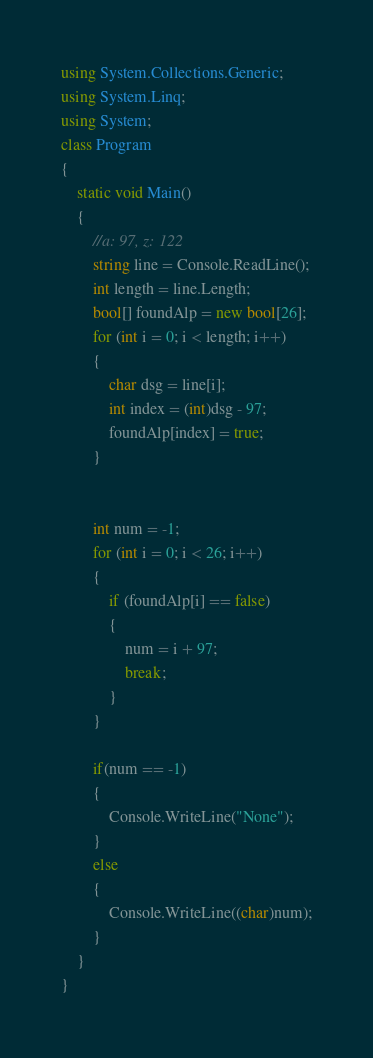<code> <loc_0><loc_0><loc_500><loc_500><_C#_>using System.Collections.Generic;
using System.Linq;
using System;
class Program
{
    static void Main()
    {
        //a: 97, z: 122
        string line = Console.ReadLine();
        int length = line.Length;
        bool[] foundAlp = new bool[26];
        for (int i = 0; i < length; i++)
        {
            char dsg = line[i];
            int index = (int)dsg - 97;
            foundAlp[index] = true;
        }


        int num = -1;
        for (int i = 0; i < 26; i++)
        {
            if (foundAlp[i] == false)
            {
                num = i + 97;
                break;
            }
        }

        if(num == -1)
        {
            Console.WriteLine("None");
        }
        else
        {
            Console.WriteLine((char)num);
        }
    }
}</code> 